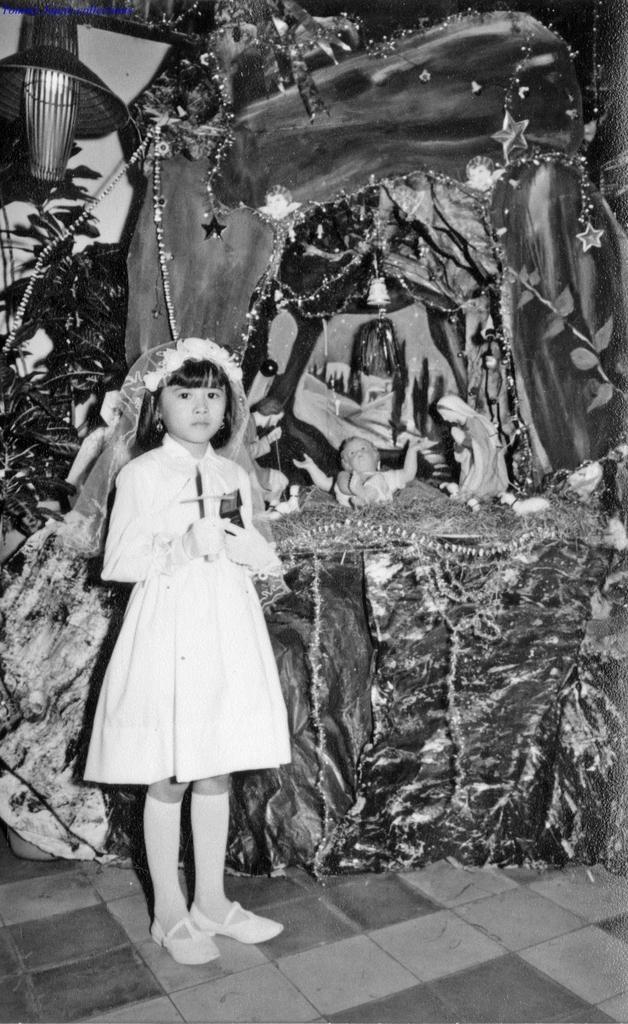Please provide a concise description of this image. This is a black and white picture. The girl in white dress is standing in front of the picture. Behind her, we see the statuettes of the woman and the baby placed on the table. This table is decorated with the decorative items. Beside that, we see a plant. In the left top of the picture, we see a lantern. 